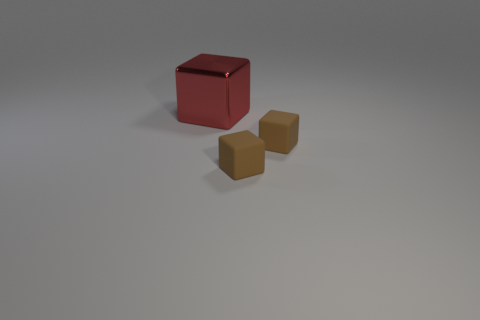Add 2 large objects. How many objects exist? 5 Add 2 red shiny things. How many red shiny things exist? 3 Subtract 0 cyan spheres. How many objects are left? 3 Subtract all brown objects. Subtract all metal objects. How many objects are left? 0 Add 3 tiny brown rubber things. How many tiny brown rubber things are left? 5 